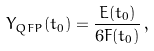<formula> <loc_0><loc_0><loc_500><loc_500>Y _ { Q F P } ( t _ { 0 } ) = \frac { E ( t _ { 0 } ) } { 6 F ( t _ { 0 } ) } \, ,</formula> 